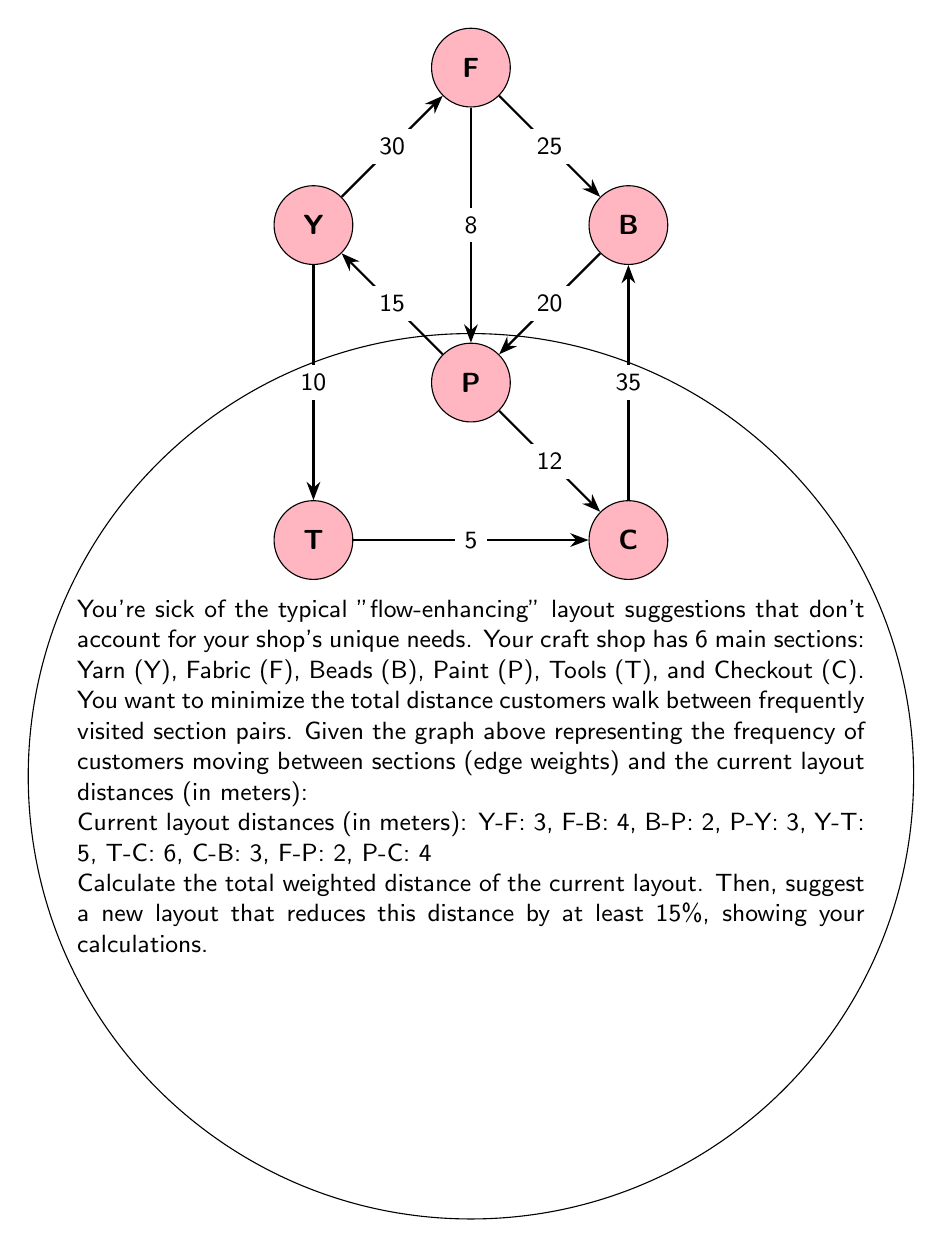What is the answer to this math problem? Let's approach this step-by-step:

1) First, calculate the current total weighted distance:
   $$\text{Total} = \sum (\text{frequency} \times \text{distance})$$
   
   Y-F: $30 \times 3 = 90$
   F-B: $25 \times 4 = 100$
   B-P: $20 \times 2 = 40$
   P-Y: $15 \times 3 = 45$
   Y-T: $10 \times 5 = 50$
   T-C: $5 \times 6 = 30$
   C-B: $35 \times 3 = 105$
   F-P: $8 \times 2 = 16$
   P-C: $12 \times 4 = 48$

   $$\text{Total} = 90 + 100 + 40 + 45 + 50 + 30 + 105 + 16 + 48 = 524$$

2) To reduce this by at least 15%, we need to get it below:
   $$524 \times 0.85 = 445.4$$

3) Let's rearrange the layout to minimize distances between frequently visited pairs:
   - Keep B and C close (highest frequency: 35)
   - Keep Y and F close (second highest: 30)
   - Keep F and B relatively close (25)
   - Keep B and P close (20)

4) A possible new layout (distances in meters):
   Y-F: 2, F-B: 3, B-P: 2, P-Y: 4, Y-T: 4, T-C: 3, C-B: 2, F-P: 3, P-C: 3

5) Calculate the new total weighted distance:
   Y-F: $30 \times 2 = 60$
   F-B: $25 \times 3 = 75$
   B-P: $20 \times 2 = 40$
   P-Y: $15 \times 4 = 60$
   Y-T: $10 \times 4 = 40$
   T-C: $5 \times 3 = 15$
   C-B: $35 \times 2 = 70$
   F-P: $8 \times 3 = 24$
   P-C: $12 \times 3 = 36$

   $$\text{New Total} = 60 + 75 + 40 + 60 + 40 + 15 + 70 + 24 + 36 = 420$$

6) Calculate the percentage reduction:
   $$\text{Reduction} = \frac{524 - 420}{524} \times 100\% = 19.85\%$$

This new layout reduces the total weighted distance by 19.85%, which is more than the required 15%.
Answer: Current total weighted distance: 524. New layout: Y-F:2m, F-B:3m, B-P:2m, P-Y:4m, Y-T:4m, T-C:3m, C-B:2m, F-P:3m, P-C:3m. New total: 420. Reduction: 19.85%. 